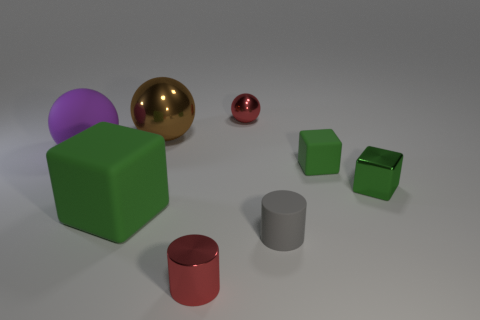Add 2 small brown metallic objects. How many objects exist? 10 Subtract all blocks. How many objects are left? 5 Add 6 small green cubes. How many small green cubes exist? 8 Subtract 1 gray cylinders. How many objects are left? 7 Subtract all tiny red things. Subtract all cylinders. How many objects are left? 4 Add 4 tiny red metal cylinders. How many tiny red metal cylinders are left? 5 